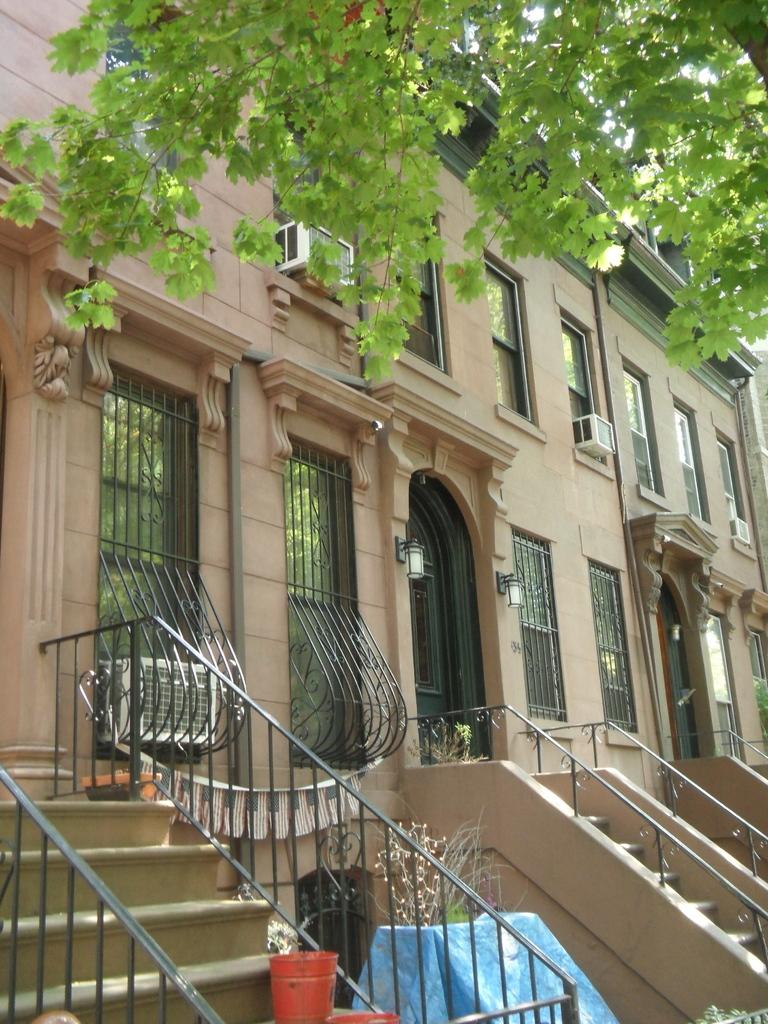What type of structure is present in the image? There is a building in the image. What color is the building? The building is cream-colored. What features can be seen on the building? There are windows and condensers on the building. What architectural element is present in the image? There are stairs in the image. What safety feature is associated with the stairs? There is a railing associated with the stairs. What type of vegetation is visible in the image? There is a tree in the image. Can you tell me how many horns are visible on the building in the image? There are no horns visible on the building in the image. Is there a volcano erupting in the background of the image? There is no volcano present in the image. 